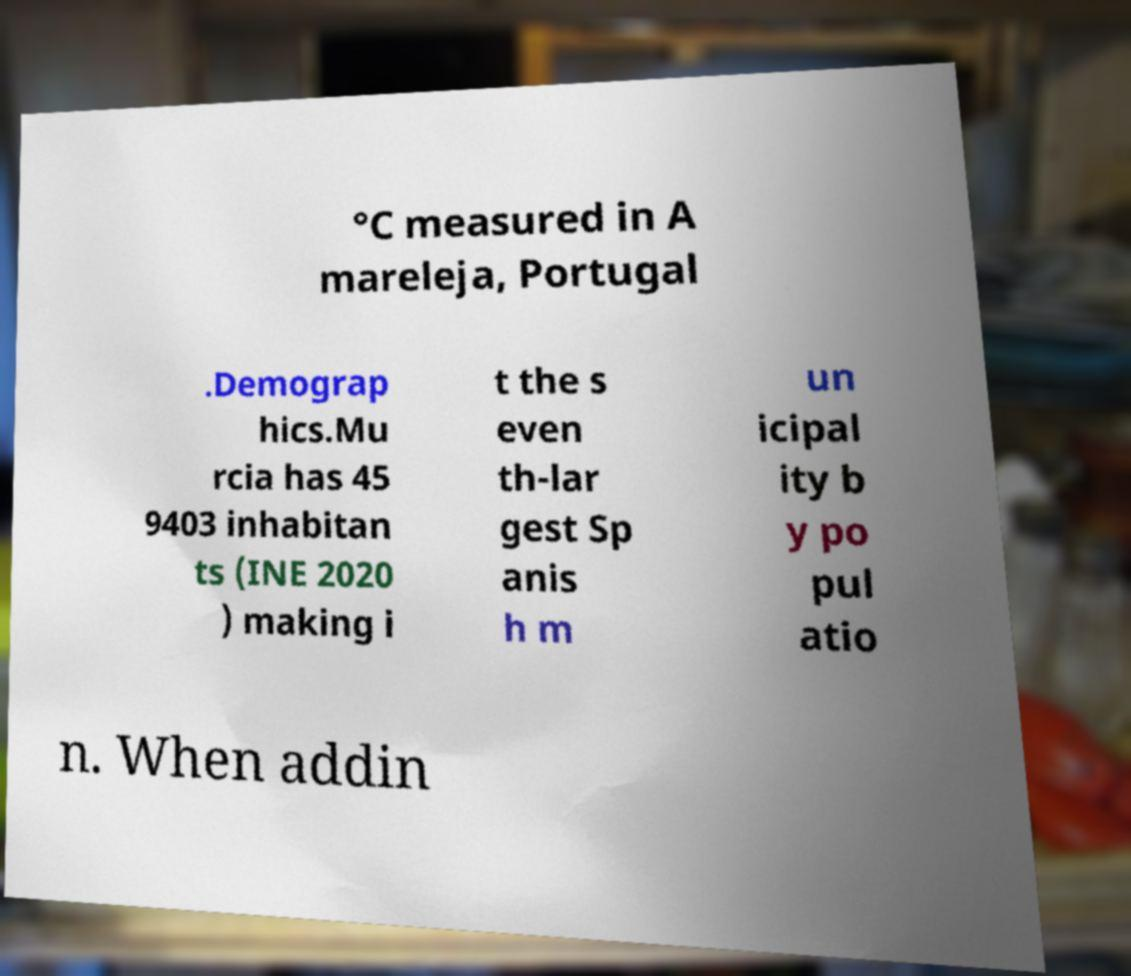Could you extract and type out the text from this image? °C measured in A mareleja, Portugal .Demograp hics.Mu rcia has 45 9403 inhabitan ts (INE 2020 ) making i t the s even th-lar gest Sp anis h m un icipal ity b y po pul atio n. When addin 